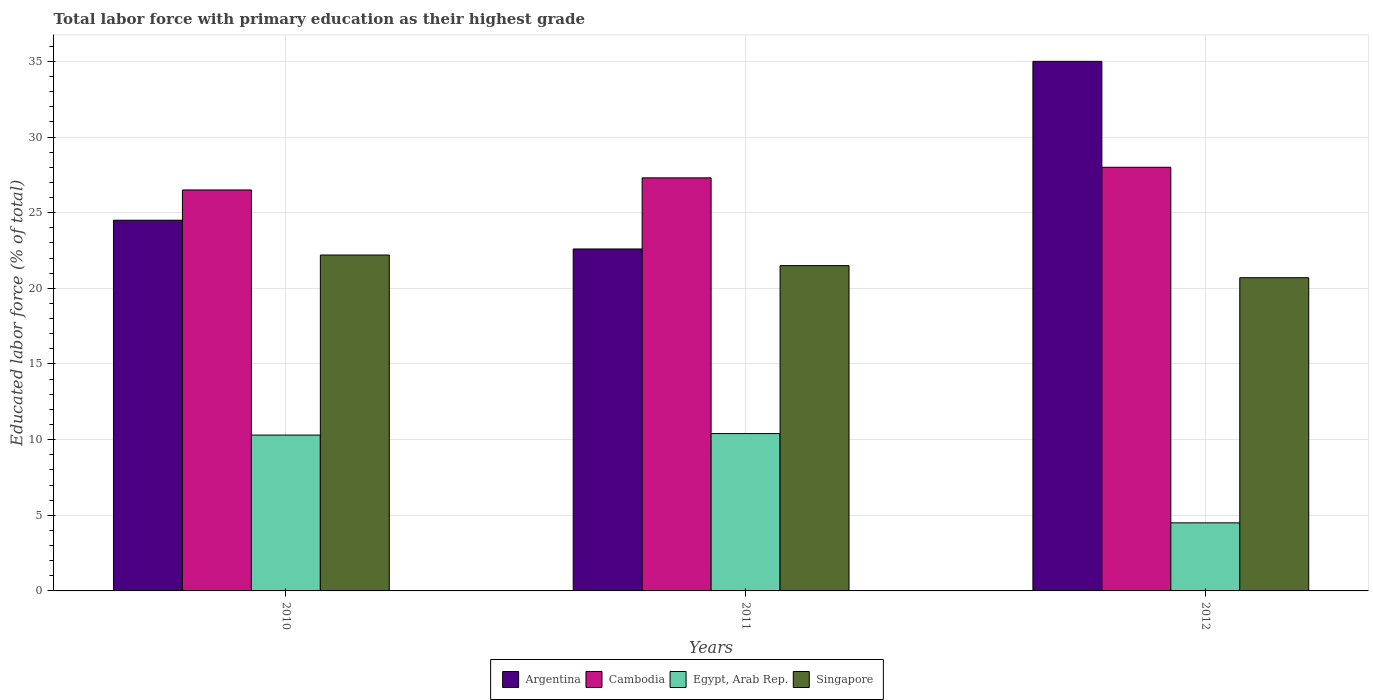How many different coloured bars are there?
Your response must be concise. 4. How many groups of bars are there?
Offer a terse response. 3. Are the number of bars on each tick of the X-axis equal?
Your response must be concise. Yes. How many bars are there on the 3rd tick from the left?
Offer a very short reply. 4. What is the label of the 2nd group of bars from the left?
Provide a short and direct response. 2011. What is the percentage of total labor force with primary education in Egypt, Arab Rep. in 2011?
Keep it short and to the point. 10.4. Across all years, what is the maximum percentage of total labor force with primary education in Cambodia?
Your response must be concise. 28. Across all years, what is the minimum percentage of total labor force with primary education in Singapore?
Give a very brief answer. 20.7. What is the total percentage of total labor force with primary education in Singapore in the graph?
Provide a short and direct response. 64.4. What is the difference between the percentage of total labor force with primary education in Cambodia in 2010 and that in 2012?
Keep it short and to the point. -1.5. What is the average percentage of total labor force with primary education in Singapore per year?
Make the answer very short. 21.47. In the year 2012, what is the difference between the percentage of total labor force with primary education in Egypt, Arab Rep. and percentage of total labor force with primary education in Cambodia?
Offer a terse response. -23.5. What is the ratio of the percentage of total labor force with primary education in Egypt, Arab Rep. in 2010 to that in 2012?
Give a very brief answer. 2.29. Is the percentage of total labor force with primary education in Argentina in 2011 less than that in 2012?
Make the answer very short. Yes. What is the difference between the highest and the second highest percentage of total labor force with primary education in Cambodia?
Keep it short and to the point. 0.7. What is the difference between the highest and the lowest percentage of total labor force with primary education in Argentina?
Offer a very short reply. 12.4. Is the sum of the percentage of total labor force with primary education in Egypt, Arab Rep. in 2010 and 2012 greater than the maximum percentage of total labor force with primary education in Argentina across all years?
Provide a short and direct response. No. What does the 3rd bar from the left in 2012 represents?
Ensure brevity in your answer.  Egypt, Arab Rep. What does the 1st bar from the right in 2012 represents?
Provide a succinct answer. Singapore. Is it the case that in every year, the sum of the percentage of total labor force with primary education in Cambodia and percentage of total labor force with primary education in Argentina is greater than the percentage of total labor force with primary education in Egypt, Arab Rep.?
Make the answer very short. Yes. How many bars are there?
Keep it short and to the point. 12. How many years are there in the graph?
Provide a succinct answer. 3. Are the values on the major ticks of Y-axis written in scientific E-notation?
Your answer should be compact. No. How many legend labels are there?
Your answer should be compact. 4. How are the legend labels stacked?
Provide a short and direct response. Horizontal. What is the title of the graph?
Keep it short and to the point. Total labor force with primary education as their highest grade. What is the label or title of the X-axis?
Give a very brief answer. Years. What is the label or title of the Y-axis?
Your answer should be very brief. Educated labor force (% of total). What is the Educated labor force (% of total) in Argentina in 2010?
Offer a terse response. 24.5. What is the Educated labor force (% of total) in Cambodia in 2010?
Your answer should be very brief. 26.5. What is the Educated labor force (% of total) in Egypt, Arab Rep. in 2010?
Make the answer very short. 10.3. What is the Educated labor force (% of total) in Singapore in 2010?
Provide a succinct answer. 22.2. What is the Educated labor force (% of total) in Argentina in 2011?
Your response must be concise. 22.6. What is the Educated labor force (% of total) of Cambodia in 2011?
Your response must be concise. 27.3. What is the Educated labor force (% of total) in Egypt, Arab Rep. in 2011?
Your answer should be compact. 10.4. What is the Educated labor force (% of total) in Cambodia in 2012?
Keep it short and to the point. 28. What is the Educated labor force (% of total) of Egypt, Arab Rep. in 2012?
Ensure brevity in your answer.  4.5. What is the Educated labor force (% of total) in Singapore in 2012?
Your answer should be compact. 20.7. Across all years, what is the maximum Educated labor force (% of total) in Argentina?
Provide a succinct answer. 35. Across all years, what is the maximum Educated labor force (% of total) of Cambodia?
Make the answer very short. 28. Across all years, what is the maximum Educated labor force (% of total) in Egypt, Arab Rep.?
Your response must be concise. 10.4. Across all years, what is the maximum Educated labor force (% of total) of Singapore?
Your response must be concise. 22.2. Across all years, what is the minimum Educated labor force (% of total) of Argentina?
Offer a terse response. 22.6. Across all years, what is the minimum Educated labor force (% of total) of Singapore?
Give a very brief answer. 20.7. What is the total Educated labor force (% of total) of Argentina in the graph?
Ensure brevity in your answer.  82.1. What is the total Educated labor force (% of total) in Cambodia in the graph?
Keep it short and to the point. 81.8. What is the total Educated labor force (% of total) of Egypt, Arab Rep. in the graph?
Your answer should be very brief. 25.2. What is the total Educated labor force (% of total) in Singapore in the graph?
Ensure brevity in your answer.  64.4. What is the difference between the Educated labor force (% of total) in Argentina in 2010 and that in 2011?
Offer a very short reply. 1.9. What is the difference between the Educated labor force (% of total) of Cambodia in 2010 and that in 2011?
Offer a very short reply. -0.8. What is the difference between the Educated labor force (% of total) in Egypt, Arab Rep. in 2010 and that in 2011?
Ensure brevity in your answer.  -0.1. What is the difference between the Educated labor force (% of total) in Singapore in 2010 and that in 2011?
Your answer should be compact. 0.7. What is the difference between the Educated labor force (% of total) of Argentina in 2010 and that in 2012?
Keep it short and to the point. -10.5. What is the difference between the Educated labor force (% of total) of Egypt, Arab Rep. in 2011 and that in 2012?
Keep it short and to the point. 5.9. What is the difference between the Educated labor force (% of total) in Singapore in 2011 and that in 2012?
Keep it short and to the point. 0.8. What is the difference between the Educated labor force (% of total) in Argentina in 2010 and the Educated labor force (% of total) in Egypt, Arab Rep. in 2011?
Offer a very short reply. 14.1. What is the difference between the Educated labor force (% of total) in Cambodia in 2010 and the Educated labor force (% of total) in Singapore in 2011?
Provide a short and direct response. 5. What is the difference between the Educated labor force (% of total) of Egypt, Arab Rep. in 2010 and the Educated labor force (% of total) of Singapore in 2011?
Give a very brief answer. -11.2. What is the difference between the Educated labor force (% of total) of Argentina in 2010 and the Educated labor force (% of total) of Singapore in 2012?
Your answer should be compact. 3.8. What is the difference between the Educated labor force (% of total) of Cambodia in 2010 and the Educated labor force (% of total) of Egypt, Arab Rep. in 2012?
Offer a terse response. 22. What is the difference between the Educated labor force (% of total) in Argentina in 2011 and the Educated labor force (% of total) in Egypt, Arab Rep. in 2012?
Provide a succinct answer. 18.1. What is the difference between the Educated labor force (% of total) in Argentina in 2011 and the Educated labor force (% of total) in Singapore in 2012?
Give a very brief answer. 1.9. What is the difference between the Educated labor force (% of total) in Cambodia in 2011 and the Educated labor force (% of total) in Egypt, Arab Rep. in 2012?
Provide a short and direct response. 22.8. What is the difference between the Educated labor force (% of total) in Cambodia in 2011 and the Educated labor force (% of total) in Singapore in 2012?
Make the answer very short. 6.6. What is the average Educated labor force (% of total) of Argentina per year?
Keep it short and to the point. 27.37. What is the average Educated labor force (% of total) in Cambodia per year?
Provide a short and direct response. 27.27. What is the average Educated labor force (% of total) in Egypt, Arab Rep. per year?
Ensure brevity in your answer.  8.4. What is the average Educated labor force (% of total) of Singapore per year?
Keep it short and to the point. 21.47. In the year 2010, what is the difference between the Educated labor force (% of total) of Argentina and Educated labor force (% of total) of Cambodia?
Provide a succinct answer. -2. In the year 2010, what is the difference between the Educated labor force (% of total) of Argentina and Educated labor force (% of total) of Egypt, Arab Rep.?
Ensure brevity in your answer.  14.2. In the year 2010, what is the difference between the Educated labor force (% of total) in Argentina and Educated labor force (% of total) in Singapore?
Your response must be concise. 2.3. In the year 2010, what is the difference between the Educated labor force (% of total) in Cambodia and Educated labor force (% of total) in Egypt, Arab Rep.?
Provide a succinct answer. 16.2. In the year 2011, what is the difference between the Educated labor force (% of total) of Argentina and Educated labor force (% of total) of Cambodia?
Keep it short and to the point. -4.7. In the year 2011, what is the difference between the Educated labor force (% of total) in Argentina and Educated labor force (% of total) in Egypt, Arab Rep.?
Keep it short and to the point. 12.2. In the year 2011, what is the difference between the Educated labor force (% of total) of Argentina and Educated labor force (% of total) of Singapore?
Offer a very short reply. 1.1. In the year 2011, what is the difference between the Educated labor force (% of total) of Cambodia and Educated labor force (% of total) of Egypt, Arab Rep.?
Make the answer very short. 16.9. In the year 2012, what is the difference between the Educated labor force (% of total) in Argentina and Educated labor force (% of total) in Egypt, Arab Rep.?
Your response must be concise. 30.5. In the year 2012, what is the difference between the Educated labor force (% of total) of Argentina and Educated labor force (% of total) of Singapore?
Ensure brevity in your answer.  14.3. In the year 2012, what is the difference between the Educated labor force (% of total) in Cambodia and Educated labor force (% of total) in Egypt, Arab Rep.?
Your response must be concise. 23.5. In the year 2012, what is the difference between the Educated labor force (% of total) of Cambodia and Educated labor force (% of total) of Singapore?
Your response must be concise. 7.3. In the year 2012, what is the difference between the Educated labor force (% of total) in Egypt, Arab Rep. and Educated labor force (% of total) in Singapore?
Keep it short and to the point. -16.2. What is the ratio of the Educated labor force (% of total) in Argentina in 2010 to that in 2011?
Provide a succinct answer. 1.08. What is the ratio of the Educated labor force (% of total) of Cambodia in 2010 to that in 2011?
Your answer should be very brief. 0.97. What is the ratio of the Educated labor force (% of total) in Singapore in 2010 to that in 2011?
Your answer should be very brief. 1.03. What is the ratio of the Educated labor force (% of total) of Argentina in 2010 to that in 2012?
Offer a terse response. 0.7. What is the ratio of the Educated labor force (% of total) of Cambodia in 2010 to that in 2012?
Give a very brief answer. 0.95. What is the ratio of the Educated labor force (% of total) in Egypt, Arab Rep. in 2010 to that in 2012?
Offer a very short reply. 2.29. What is the ratio of the Educated labor force (% of total) in Singapore in 2010 to that in 2012?
Provide a short and direct response. 1.07. What is the ratio of the Educated labor force (% of total) in Argentina in 2011 to that in 2012?
Your response must be concise. 0.65. What is the ratio of the Educated labor force (% of total) of Cambodia in 2011 to that in 2012?
Provide a short and direct response. 0.97. What is the ratio of the Educated labor force (% of total) in Egypt, Arab Rep. in 2011 to that in 2012?
Ensure brevity in your answer.  2.31. What is the ratio of the Educated labor force (% of total) in Singapore in 2011 to that in 2012?
Your answer should be compact. 1.04. What is the difference between the highest and the second highest Educated labor force (% of total) in Argentina?
Provide a short and direct response. 10.5. What is the difference between the highest and the second highest Educated labor force (% of total) of Cambodia?
Give a very brief answer. 0.7. What is the difference between the highest and the second highest Educated labor force (% of total) in Egypt, Arab Rep.?
Ensure brevity in your answer.  0.1. What is the difference between the highest and the lowest Educated labor force (% of total) of Argentina?
Your response must be concise. 12.4. What is the difference between the highest and the lowest Educated labor force (% of total) of Egypt, Arab Rep.?
Provide a succinct answer. 5.9. What is the difference between the highest and the lowest Educated labor force (% of total) in Singapore?
Your answer should be compact. 1.5. 